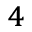Convert formula to latex. <formula><loc_0><loc_0><loc_500><loc_500>^ { 4 }</formula> 